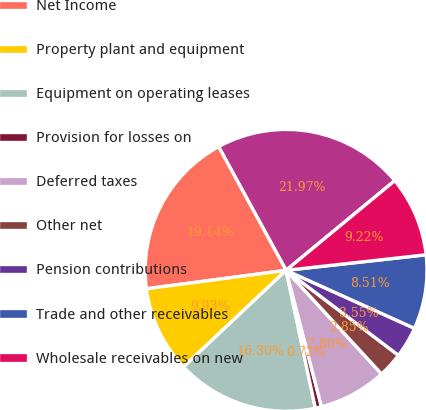Convert chart to OTSL. <chart><loc_0><loc_0><loc_500><loc_500><pie_chart><fcel>Year Ended December 31<fcel>Net Income<fcel>Property plant and equipment<fcel>Equipment on operating leases<fcel>Provision for losses on<fcel>Deferred taxes<fcel>Other net<fcel>Pension contributions<fcel>Trade and other receivables<fcel>Wholesale receivables on new<nl><fcel>21.97%<fcel>19.14%<fcel>9.93%<fcel>16.3%<fcel>0.72%<fcel>7.8%<fcel>2.85%<fcel>3.55%<fcel>8.51%<fcel>9.22%<nl></chart> 